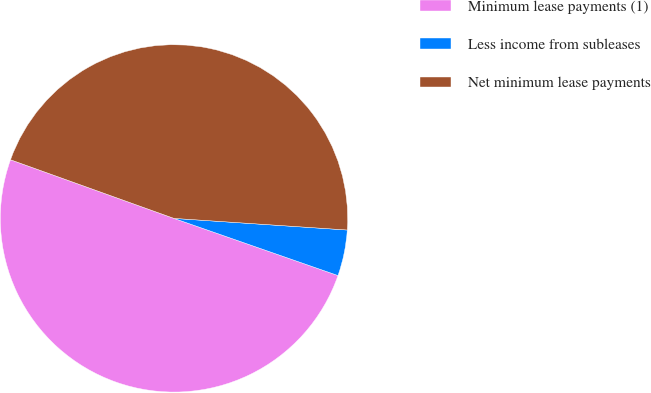Convert chart. <chart><loc_0><loc_0><loc_500><loc_500><pie_chart><fcel>Minimum lease payments (1)<fcel>Less income from subleases<fcel>Net minimum lease payments<nl><fcel>50.15%<fcel>4.27%<fcel>45.59%<nl></chart> 